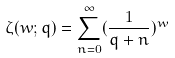Convert formula to latex. <formula><loc_0><loc_0><loc_500><loc_500>\zeta ( w ; q ) = \sum _ { n = 0 } ^ { \infty } ( \frac { 1 } { q + n } ) ^ { w }</formula> 